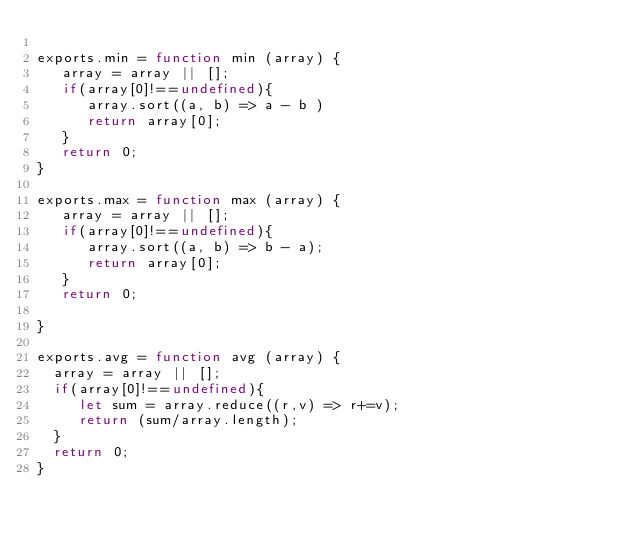Convert code to text. <code><loc_0><loc_0><loc_500><loc_500><_JavaScript_>
exports.min = function min (array) {
   array = array || [];
   if(array[0]!==undefined){
      array.sort((a, b) => a - b )
      return array[0];
   }
   return 0;
}

exports.max = function max (array) {
   array = array || [];
   if(array[0]!==undefined){
      array.sort((a, b) => b - a);
      return array[0];
   }
   return 0;

}

exports.avg = function avg (array) {
  array = array || [];
  if(array[0]!==undefined){
     let sum = array.reduce((r,v) => r+=v);
     return (sum/array.length);
  }
  return 0;
}
</code> 